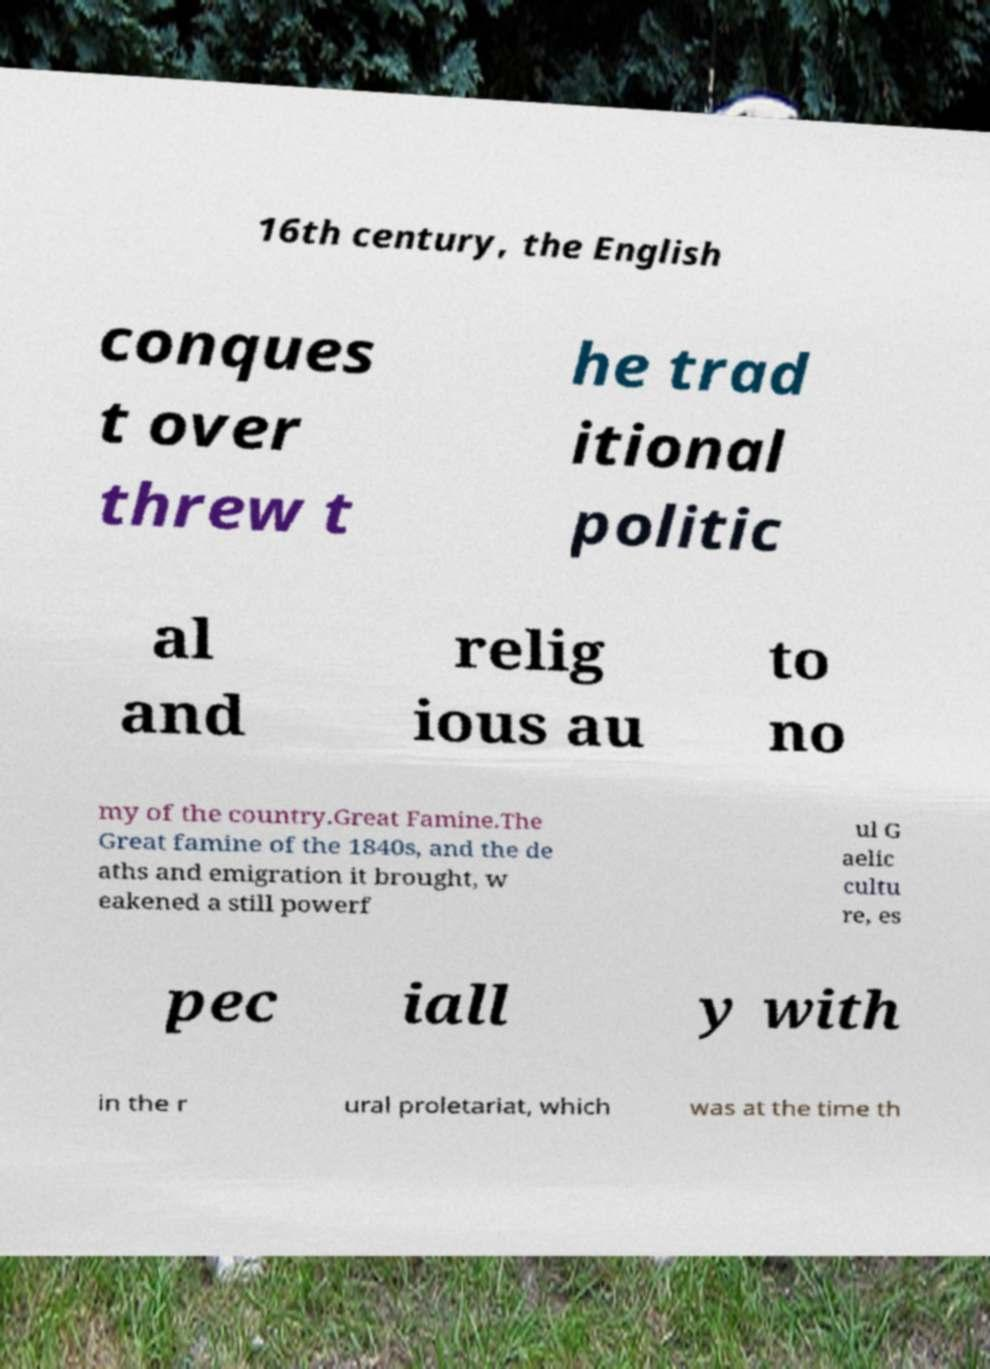Could you assist in decoding the text presented in this image and type it out clearly? 16th century, the English conques t over threw t he trad itional politic al and relig ious au to no my of the country.Great Famine.The Great famine of the 1840s, and the de aths and emigration it brought, w eakened a still powerf ul G aelic cultu re, es pec iall y with in the r ural proletariat, which was at the time th 